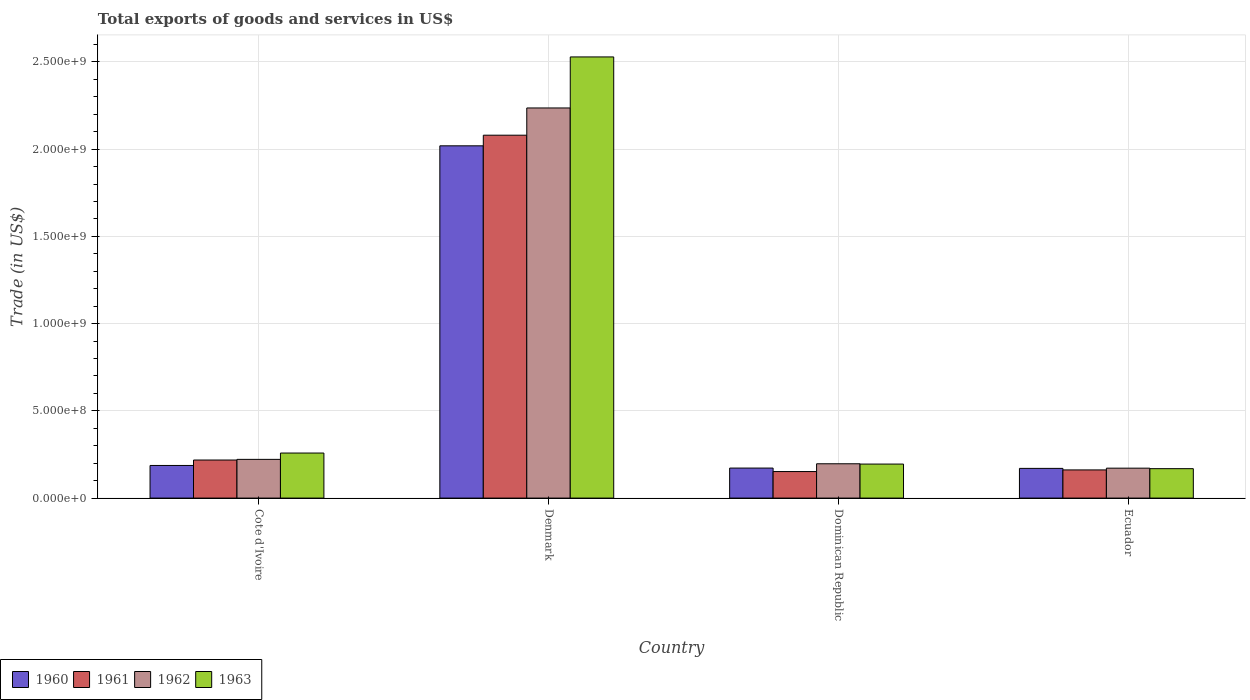How many different coloured bars are there?
Ensure brevity in your answer.  4. How many groups of bars are there?
Provide a short and direct response. 4. How many bars are there on the 3rd tick from the right?
Your response must be concise. 4. What is the label of the 2nd group of bars from the left?
Keep it short and to the point. Denmark. What is the total exports of goods and services in 1962 in Denmark?
Give a very brief answer. 2.24e+09. Across all countries, what is the maximum total exports of goods and services in 1960?
Make the answer very short. 2.02e+09. Across all countries, what is the minimum total exports of goods and services in 1963?
Give a very brief answer. 1.69e+08. In which country was the total exports of goods and services in 1961 minimum?
Provide a succinct answer. Dominican Republic. What is the total total exports of goods and services in 1963 in the graph?
Give a very brief answer. 3.15e+09. What is the difference between the total exports of goods and services in 1961 in Cote d'Ivoire and that in Dominican Republic?
Keep it short and to the point. 6.61e+07. What is the difference between the total exports of goods and services in 1960 in Dominican Republic and the total exports of goods and services in 1963 in Denmark?
Ensure brevity in your answer.  -2.36e+09. What is the average total exports of goods and services in 1962 per country?
Keep it short and to the point. 7.07e+08. What is the difference between the total exports of goods and services of/in 1960 and total exports of goods and services of/in 1961 in Denmark?
Your answer should be compact. -6.09e+07. What is the ratio of the total exports of goods and services in 1962 in Dominican Republic to that in Ecuador?
Provide a short and direct response. 1.15. Is the total exports of goods and services in 1963 in Cote d'Ivoire less than that in Denmark?
Your response must be concise. Yes. What is the difference between the highest and the second highest total exports of goods and services in 1961?
Ensure brevity in your answer.  1.92e+09. What is the difference between the highest and the lowest total exports of goods and services in 1962?
Keep it short and to the point. 2.06e+09. In how many countries, is the total exports of goods and services in 1962 greater than the average total exports of goods and services in 1962 taken over all countries?
Provide a succinct answer. 1. Is it the case that in every country, the sum of the total exports of goods and services in 1962 and total exports of goods and services in 1961 is greater than the total exports of goods and services in 1960?
Make the answer very short. Yes. How many bars are there?
Ensure brevity in your answer.  16. How many countries are there in the graph?
Offer a very short reply. 4. What is the difference between two consecutive major ticks on the Y-axis?
Your response must be concise. 5.00e+08. Are the values on the major ticks of Y-axis written in scientific E-notation?
Offer a very short reply. Yes. Does the graph contain any zero values?
Give a very brief answer. No. Does the graph contain grids?
Provide a short and direct response. Yes. Where does the legend appear in the graph?
Give a very brief answer. Bottom left. How are the legend labels stacked?
Your answer should be compact. Horizontal. What is the title of the graph?
Your response must be concise. Total exports of goods and services in US$. What is the label or title of the Y-axis?
Give a very brief answer. Trade (in US$). What is the Trade (in US$) of 1960 in Cote d'Ivoire?
Make the answer very short. 1.87e+08. What is the Trade (in US$) in 1961 in Cote d'Ivoire?
Provide a succinct answer. 2.18e+08. What is the Trade (in US$) in 1962 in Cote d'Ivoire?
Make the answer very short. 2.22e+08. What is the Trade (in US$) of 1963 in Cote d'Ivoire?
Provide a succinct answer. 2.58e+08. What is the Trade (in US$) in 1960 in Denmark?
Ensure brevity in your answer.  2.02e+09. What is the Trade (in US$) of 1961 in Denmark?
Offer a very short reply. 2.08e+09. What is the Trade (in US$) of 1962 in Denmark?
Provide a succinct answer. 2.24e+09. What is the Trade (in US$) in 1963 in Denmark?
Offer a very short reply. 2.53e+09. What is the Trade (in US$) in 1960 in Dominican Republic?
Your answer should be compact. 1.72e+08. What is the Trade (in US$) of 1961 in Dominican Republic?
Keep it short and to the point. 1.52e+08. What is the Trade (in US$) of 1962 in Dominican Republic?
Give a very brief answer. 1.97e+08. What is the Trade (in US$) in 1963 in Dominican Republic?
Ensure brevity in your answer.  1.95e+08. What is the Trade (in US$) of 1960 in Ecuador?
Give a very brief answer. 1.70e+08. What is the Trade (in US$) in 1961 in Ecuador?
Give a very brief answer. 1.61e+08. What is the Trade (in US$) of 1962 in Ecuador?
Your answer should be compact. 1.71e+08. What is the Trade (in US$) in 1963 in Ecuador?
Provide a succinct answer. 1.69e+08. Across all countries, what is the maximum Trade (in US$) of 1960?
Keep it short and to the point. 2.02e+09. Across all countries, what is the maximum Trade (in US$) of 1961?
Provide a succinct answer. 2.08e+09. Across all countries, what is the maximum Trade (in US$) of 1962?
Your answer should be very brief. 2.24e+09. Across all countries, what is the maximum Trade (in US$) of 1963?
Offer a very short reply. 2.53e+09. Across all countries, what is the minimum Trade (in US$) in 1960?
Make the answer very short. 1.70e+08. Across all countries, what is the minimum Trade (in US$) of 1961?
Keep it short and to the point. 1.52e+08. Across all countries, what is the minimum Trade (in US$) of 1962?
Provide a succinct answer. 1.71e+08. Across all countries, what is the minimum Trade (in US$) in 1963?
Your response must be concise. 1.69e+08. What is the total Trade (in US$) of 1960 in the graph?
Provide a short and direct response. 2.55e+09. What is the total Trade (in US$) of 1961 in the graph?
Your answer should be very brief. 2.61e+09. What is the total Trade (in US$) of 1962 in the graph?
Make the answer very short. 2.83e+09. What is the total Trade (in US$) in 1963 in the graph?
Ensure brevity in your answer.  3.15e+09. What is the difference between the Trade (in US$) in 1960 in Cote d'Ivoire and that in Denmark?
Provide a succinct answer. -1.83e+09. What is the difference between the Trade (in US$) of 1961 in Cote d'Ivoire and that in Denmark?
Offer a very short reply. -1.86e+09. What is the difference between the Trade (in US$) in 1962 in Cote d'Ivoire and that in Denmark?
Make the answer very short. -2.01e+09. What is the difference between the Trade (in US$) in 1963 in Cote d'Ivoire and that in Denmark?
Provide a succinct answer. -2.27e+09. What is the difference between the Trade (in US$) of 1960 in Cote d'Ivoire and that in Dominican Republic?
Provide a short and direct response. 1.49e+07. What is the difference between the Trade (in US$) in 1961 in Cote d'Ivoire and that in Dominican Republic?
Offer a terse response. 6.61e+07. What is the difference between the Trade (in US$) in 1962 in Cote d'Ivoire and that in Dominican Republic?
Ensure brevity in your answer.  2.52e+07. What is the difference between the Trade (in US$) in 1963 in Cote d'Ivoire and that in Dominican Republic?
Offer a very short reply. 6.33e+07. What is the difference between the Trade (in US$) in 1960 in Cote d'Ivoire and that in Ecuador?
Your response must be concise. 1.68e+07. What is the difference between the Trade (in US$) of 1961 in Cote d'Ivoire and that in Ecuador?
Your answer should be compact. 5.67e+07. What is the difference between the Trade (in US$) of 1962 in Cote d'Ivoire and that in Ecuador?
Your answer should be very brief. 5.04e+07. What is the difference between the Trade (in US$) of 1963 in Cote d'Ivoire and that in Ecuador?
Offer a terse response. 8.96e+07. What is the difference between the Trade (in US$) of 1960 in Denmark and that in Dominican Republic?
Offer a very short reply. 1.85e+09. What is the difference between the Trade (in US$) in 1961 in Denmark and that in Dominican Republic?
Make the answer very short. 1.93e+09. What is the difference between the Trade (in US$) in 1962 in Denmark and that in Dominican Republic?
Give a very brief answer. 2.04e+09. What is the difference between the Trade (in US$) of 1963 in Denmark and that in Dominican Republic?
Your response must be concise. 2.33e+09. What is the difference between the Trade (in US$) of 1960 in Denmark and that in Ecuador?
Offer a very short reply. 1.85e+09. What is the difference between the Trade (in US$) in 1961 in Denmark and that in Ecuador?
Make the answer very short. 1.92e+09. What is the difference between the Trade (in US$) in 1962 in Denmark and that in Ecuador?
Provide a short and direct response. 2.06e+09. What is the difference between the Trade (in US$) in 1963 in Denmark and that in Ecuador?
Provide a succinct answer. 2.36e+09. What is the difference between the Trade (in US$) of 1960 in Dominican Republic and that in Ecuador?
Ensure brevity in your answer.  1.84e+06. What is the difference between the Trade (in US$) in 1961 in Dominican Republic and that in Ecuador?
Ensure brevity in your answer.  -9.39e+06. What is the difference between the Trade (in US$) of 1962 in Dominican Republic and that in Ecuador?
Provide a short and direct response. 2.52e+07. What is the difference between the Trade (in US$) in 1963 in Dominican Republic and that in Ecuador?
Offer a terse response. 2.63e+07. What is the difference between the Trade (in US$) of 1960 in Cote d'Ivoire and the Trade (in US$) of 1961 in Denmark?
Your response must be concise. -1.89e+09. What is the difference between the Trade (in US$) of 1960 in Cote d'Ivoire and the Trade (in US$) of 1962 in Denmark?
Your response must be concise. -2.05e+09. What is the difference between the Trade (in US$) in 1960 in Cote d'Ivoire and the Trade (in US$) in 1963 in Denmark?
Give a very brief answer. -2.34e+09. What is the difference between the Trade (in US$) in 1961 in Cote d'Ivoire and the Trade (in US$) in 1962 in Denmark?
Your response must be concise. -2.02e+09. What is the difference between the Trade (in US$) of 1961 in Cote d'Ivoire and the Trade (in US$) of 1963 in Denmark?
Provide a short and direct response. -2.31e+09. What is the difference between the Trade (in US$) in 1962 in Cote d'Ivoire and the Trade (in US$) in 1963 in Denmark?
Ensure brevity in your answer.  -2.31e+09. What is the difference between the Trade (in US$) in 1960 in Cote d'Ivoire and the Trade (in US$) in 1961 in Dominican Republic?
Provide a short and direct response. 3.49e+07. What is the difference between the Trade (in US$) in 1960 in Cote d'Ivoire and the Trade (in US$) in 1962 in Dominican Republic?
Your answer should be compact. -9.68e+06. What is the difference between the Trade (in US$) of 1960 in Cote d'Ivoire and the Trade (in US$) of 1963 in Dominican Republic?
Make the answer very short. -7.98e+06. What is the difference between the Trade (in US$) of 1961 in Cote d'Ivoire and the Trade (in US$) of 1962 in Dominican Republic?
Give a very brief answer. 2.15e+07. What is the difference between the Trade (in US$) of 1961 in Cote d'Ivoire and the Trade (in US$) of 1963 in Dominican Republic?
Make the answer very short. 2.32e+07. What is the difference between the Trade (in US$) of 1962 in Cote d'Ivoire and the Trade (in US$) of 1963 in Dominican Republic?
Your answer should be very brief. 2.69e+07. What is the difference between the Trade (in US$) of 1960 in Cote d'Ivoire and the Trade (in US$) of 1961 in Ecuador?
Your response must be concise. 2.55e+07. What is the difference between the Trade (in US$) of 1960 in Cote d'Ivoire and the Trade (in US$) of 1962 in Ecuador?
Provide a succinct answer. 1.55e+07. What is the difference between the Trade (in US$) of 1960 in Cote d'Ivoire and the Trade (in US$) of 1963 in Ecuador?
Provide a succinct answer. 1.83e+07. What is the difference between the Trade (in US$) of 1961 in Cote d'Ivoire and the Trade (in US$) of 1962 in Ecuador?
Ensure brevity in your answer.  4.67e+07. What is the difference between the Trade (in US$) in 1961 in Cote d'Ivoire and the Trade (in US$) in 1963 in Ecuador?
Provide a short and direct response. 4.95e+07. What is the difference between the Trade (in US$) in 1962 in Cote d'Ivoire and the Trade (in US$) in 1963 in Ecuador?
Give a very brief answer. 5.32e+07. What is the difference between the Trade (in US$) in 1960 in Denmark and the Trade (in US$) in 1961 in Dominican Republic?
Keep it short and to the point. 1.87e+09. What is the difference between the Trade (in US$) in 1960 in Denmark and the Trade (in US$) in 1962 in Dominican Republic?
Offer a very short reply. 1.82e+09. What is the difference between the Trade (in US$) of 1960 in Denmark and the Trade (in US$) of 1963 in Dominican Republic?
Your answer should be very brief. 1.82e+09. What is the difference between the Trade (in US$) in 1961 in Denmark and the Trade (in US$) in 1962 in Dominican Republic?
Provide a succinct answer. 1.88e+09. What is the difference between the Trade (in US$) in 1961 in Denmark and the Trade (in US$) in 1963 in Dominican Republic?
Give a very brief answer. 1.88e+09. What is the difference between the Trade (in US$) of 1962 in Denmark and the Trade (in US$) of 1963 in Dominican Republic?
Ensure brevity in your answer.  2.04e+09. What is the difference between the Trade (in US$) in 1960 in Denmark and the Trade (in US$) in 1961 in Ecuador?
Give a very brief answer. 1.86e+09. What is the difference between the Trade (in US$) in 1960 in Denmark and the Trade (in US$) in 1962 in Ecuador?
Give a very brief answer. 1.85e+09. What is the difference between the Trade (in US$) in 1960 in Denmark and the Trade (in US$) in 1963 in Ecuador?
Provide a succinct answer. 1.85e+09. What is the difference between the Trade (in US$) in 1961 in Denmark and the Trade (in US$) in 1962 in Ecuador?
Your answer should be very brief. 1.91e+09. What is the difference between the Trade (in US$) of 1961 in Denmark and the Trade (in US$) of 1963 in Ecuador?
Your response must be concise. 1.91e+09. What is the difference between the Trade (in US$) in 1962 in Denmark and the Trade (in US$) in 1963 in Ecuador?
Keep it short and to the point. 2.07e+09. What is the difference between the Trade (in US$) of 1960 in Dominican Republic and the Trade (in US$) of 1961 in Ecuador?
Give a very brief answer. 1.06e+07. What is the difference between the Trade (in US$) in 1960 in Dominican Republic and the Trade (in US$) in 1962 in Ecuador?
Keep it short and to the point. 6.09e+05. What is the difference between the Trade (in US$) of 1960 in Dominican Republic and the Trade (in US$) of 1963 in Ecuador?
Offer a terse response. 3.40e+06. What is the difference between the Trade (in US$) of 1961 in Dominican Republic and the Trade (in US$) of 1962 in Ecuador?
Your answer should be very brief. -1.94e+07. What is the difference between the Trade (in US$) in 1961 in Dominican Republic and the Trade (in US$) in 1963 in Ecuador?
Give a very brief answer. -1.66e+07. What is the difference between the Trade (in US$) in 1962 in Dominican Republic and the Trade (in US$) in 1963 in Ecuador?
Provide a succinct answer. 2.80e+07. What is the average Trade (in US$) in 1960 per country?
Give a very brief answer. 6.37e+08. What is the average Trade (in US$) in 1961 per country?
Your answer should be very brief. 6.53e+08. What is the average Trade (in US$) in 1962 per country?
Provide a succinct answer. 7.07e+08. What is the average Trade (in US$) of 1963 per country?
Your answer should be compact. 7.88e+08. What is the difference between the Trade (in US$) in 1960 and Trade (in US$) in 1961 in Cote d'Ivoire?
Provide a succinct answer. -3.12e+07. What is the difference between the Trade (in US$) of 1960 and Trade (in US$) of 1962 in Cote d'Ivoire?
Your answer should be compact. -3.49e+07. What is the difference between the Trade (in US$) of 1960 and Trade (in US$) of 1963 in Cote d'Ivoire?
Ensure brevity in your answer.  -7.12e+07. What is the difference between the Trade (in US$) of 1961 and Trade (in US$) of 1962 in Cote d'Ivoire?
Offer a terse response. -3.74e+06. What is the difference between the Trade (in US$) of 1961 and Trade (in US$) of 1963 in Cote d'Ivoire?
Your response must be concise. -4.01e+07. What is the difference between the Trade (in US$) of 1962 and Trade (in US$) of 1963 in Cote d'Ivoire?
Give a very brief answer. -3.63e+07. What is the difference between the Trade (in US$) in 1960 and Trade (in US$) in 1961 in Denmark?
Offer a terse response. -6.09e+07. What is the difference between the Trade (in US$) in 1960 and Trade (in US$) in 1962 in Denmark?
Offer a terse response. -2.17e+08. What is the difference between the Trade (in US$) in 1960 and Trade (in US$) in 1963 in Denmark?
Your answer should be very brief. -5.09e+08. What is the difference between the Trade (in US$) in 1961 and Trade (in US$) in 1962 in Denmark?
Make the answer very short. -1.56e+08. What is the difference between the Trade (in US$) of 1961 and Trade (in US$) of 1963 in Denmark?
Your answer should be compact. -4.49e+08. What is the difference between the Trade (in US$) of 1962 and Trade (in US$) of 1963 in Denmark?
Keep it short and to the point. -2.92e+08. What is the difference between the Trade (in US$) of 1960 and Trade (in US$) of 1961 in Dominican Republic?
Make the answer very short. 2.00e+07. What is the difference between the Trade (in US$) of 1960 and Trade (in US$) of 1962 in Dominican Republic?
Offer a terse response. -2.46e+07. What is the difference between the Trade (in US$) in 1960 and Trade (in US$) in 1963 in Dominican Republic?
Your answer should be compact. -2.29e+07. What is the difference between the Trade (in US$) of 1961 and Trade (in US$) of 1962 in Dominican Republic?
Keep it short and to the point. -4.46e+07. What is the difference between the Trade (in US$) in 1961 and Trade (in US$) in 1963 in Dominican Republic?
Give a very brief answer. -4.29e+07. What is the difference between the Trade (in US$) in 1962 and Trade (in US$) in 1963 in Dominican Republic?
Offer a terse response. 1.70e+06. What is the difference between the Trade (in US$) in 1960 and Trade (in US$) in 1961 in Ecuador?
Provide a succinct answer. 8.78e+06. What is the difference between the Trade (in US$) in 1960 and Trade (in US$) in 1962 in Ecuador?
Keep it short and to the point. -1.23e+06. What is the difference between the Trade (in US$) of 1960 and Trade (in US$) of 1963 in Ecuador?
Offer a very short reply. 1.56e+06. What is the difference between the Trade (in US$) in 1961 and Trade (in US$) in 1962 in Ecuador?
Keep it short and to the point. -1.00e+07. What is the difference between the Trade (in US$) in 1961 and Trade (in US$) in 1963 in Ecuador?
Give a very brief answer. -7.21e+06. What is the difference between the Trade (in US$) of 1962 and Trade (in US$) of 1963 in Ecuador?
Your response must be concise. 2.79e+06. What is the ratio of the Trade (in US$) in 1960 in Cote d'Ivoire to that in Denmark?
Offer a terse response. 0.09. What is the ratio of the Trade (in US$) in 1961 in Cote d'Ivoire to that in Denmark?
Make the answer very short. 0.1. What is the ratio of the Trade (in US$) of 1962 in Cote d'Ivoire to that in Denmark?
Offer a terse response. 0.1. What is the ratio of the Trade (in US$) of 1963 in Cote d'Ivoire to that in Denmark?
Your answer should be very brief. 0.1. What is the ratio of the Trade (in US$) of 1960 in Cote d'Ivoire to that in Dominican Republic?
Give a very brief answer. 1.09. What is the ratio of the Trade (in US$) in 1961 in Cote d'Ivoire to that in Dominican Republic?
Offer a very short reply. 1.43. What is the ratio of the Trade (in US$) in 1962 in Cote d'Ivoire to that in Dominican Republic?
Your answer should be very brief. 1.13. What is the ratio of the Trade (in US$) of 1963 in Cote d'Ivoire to that in Dominican Republic?
Your answer should be very brief. 1.32. What is the ratio of the Trade (in US$) in 1960 in Cote d'Ivoire to that in Ecuador?
Your answer should be compact. 1.1. What is the ratio of the Trade (in US$) in 1961 in Cote d'Ivoire to that in Ecuador?
Your answer should be compact. 1.35. What is the ratio of the Trade (in US$) in 1962 in Cote d'Ivoire to that in Ecuador?
Provide a short and direct response. 1.29. What is the ratio of the Trade (in US$) of 1963 in Cote d'Ivoire to that in Ecuador?
Make the answer very short. 1.53. What is the ratio of the Trade (in US$) in 1960 in Denmark to that in Dominican Republic?
Provide a short and direct response. 11.73. What is the ratio of the Trade (in US$) of 1961 in Denmark to that in Dominican Republic?
Your answer should be compact. 13.67. What is the ratio of the Trade (in US$) of 1962 in Denmark to that in Dominican Republic?
Your answer should be compact. 11.37. What is the ratio of the Trade (in US$) in 1963 in Denmark to that in Dominican Republic?
Provide a short and direct response. 12.97. What is the ratio of the Trade (in US$) of 1960 in Denmark to that in Ecuador?
Offer a terse response. 11.86. What is the ratio of the Trade (in US$) in 1961 in Denmark to that in Ecuador?
Your response must be concise. 12.88. What is the ratio of the Trade (in US$) of 1962 in Denmark to that in Ecuador?
Provide a short and direct response. 13.04. What is the ratio of the Trade (in US$) in 1963 in Denmark to that in Ecuador?
Provide a short and direct response. 14.99. What is the ratio of the Trade (in US$) in 1960 in Dominican Republic to that in Ecuador?
Provide a succinct answer. 1.01. What is the ratio of the Trade (in US$) of 1961 in Dominican Republic to that in Ecuador?
Offer a terse response. 0.94. What is the ratio of the Trade (in US$) of 1962 in Dominican Republic to that in Ecuador?
Provide a short and direct response. 1.15. What is the ratio of the Trade (in US$) in 1963 in Dominican Republic to that in Ecuador?
Your answer should be very brief. 1.16. What is the difference between the highest and the second highest Trade (in US$) of 1960?
Your response must be concise. 1.83e+09. What is the difference between the highest and the second highest Trade (in US$) of 1961?
Offer a very short reply. 1.86e+09. What is the difference between the highest and the second highest Trade (in US$) of 1962?
Your answer should be compact. 2.01e+09. What is the difference between the highest and the second highest Trade (in US$) in 1963?
Your answer should be very brief. 2.27e+09. What is the difference between the highest and the lowest Trade (in US$) of 1960?
Your response must be concise. 1.85e+09. What is the difference between the highest and the lowest Trade (in US$) in 1961?
Ensure brevity in your answer.  1.93e+09. What is the difference between the highest and the lowest Trade (in US$) of 1962?
Offer a very short reply. 2.06e+09. What is the difference between the highest and the lowest Trade (in US$) in 1963?
Provide a succinct answer. 2.36e+09. 